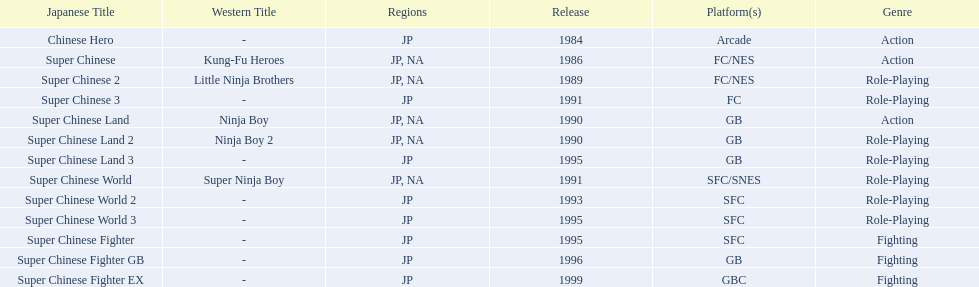Of the titles released in north america, which had the least releases? Super Chinese World. 